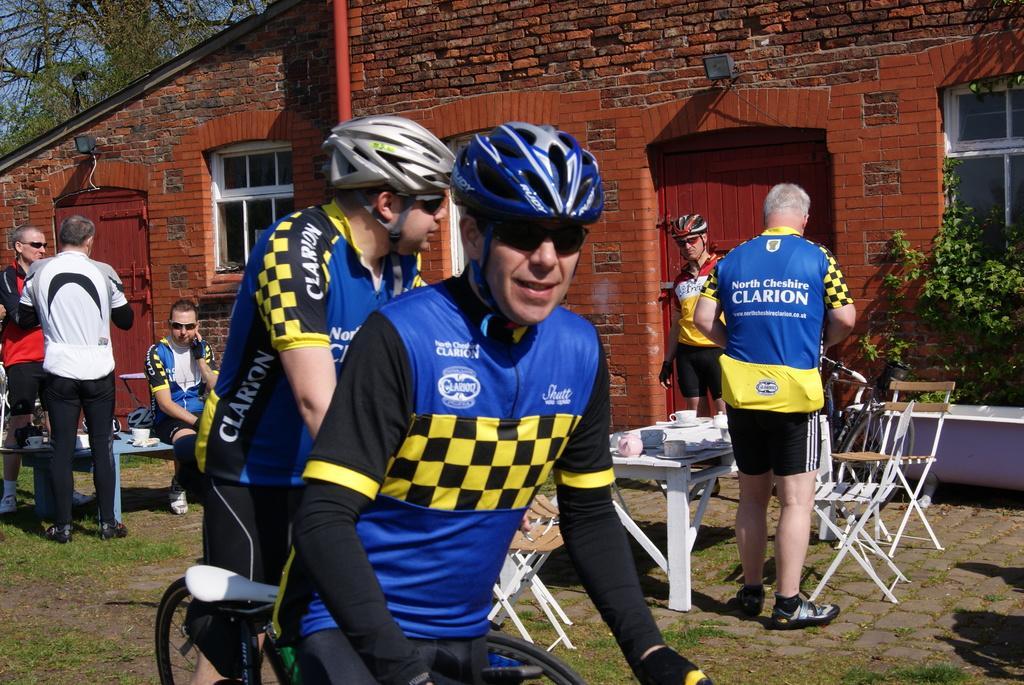In one or two sentences, can you explain what this image depicts? In this image I can see few persons wearing blue, black and yellow colored dress are riding bicycles on the ground. In the background I can see few persons standing, a person sitting on a bench, a table , few cups and few other objects on the table, a bicycle, a house which is brown and black in color, few windows of the building, few trees and the sky. 